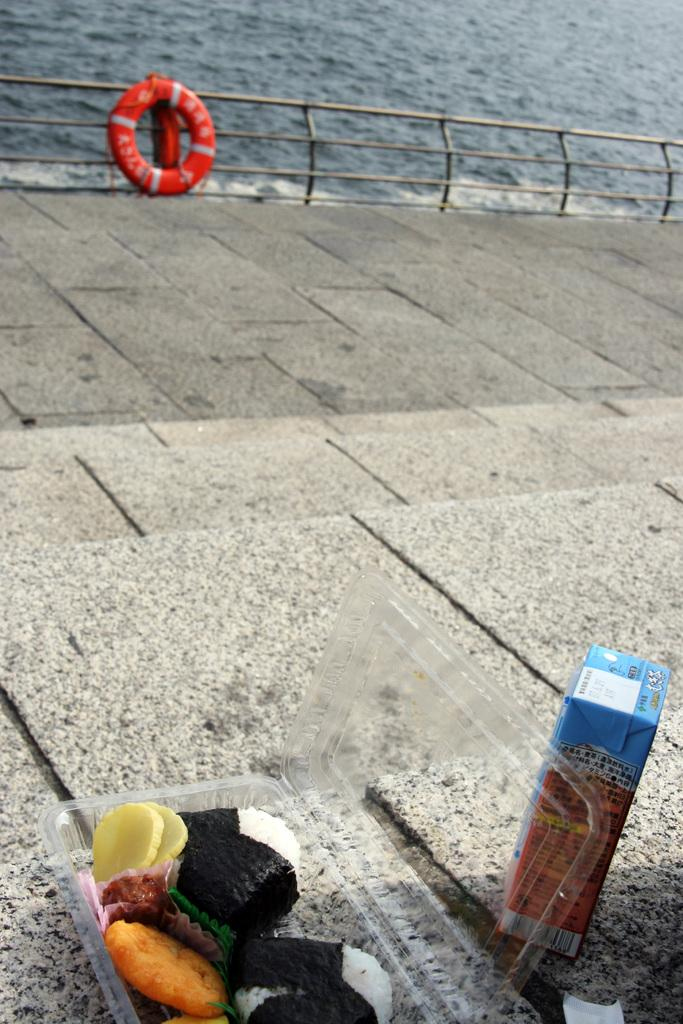What is the color of the tube in the image? The tube in the image is red. What types of containers are present in the image? There is a paper box and a plastic box in the image. What can be found inside the boxes? Different types of food are visible in the boxes. What can be seen in the background of the image? There is water visible in the background of the image. What type of cream is being delivered by the truck in the image? There is no truck present in the image, and therefore no cream delivery can be observed. 